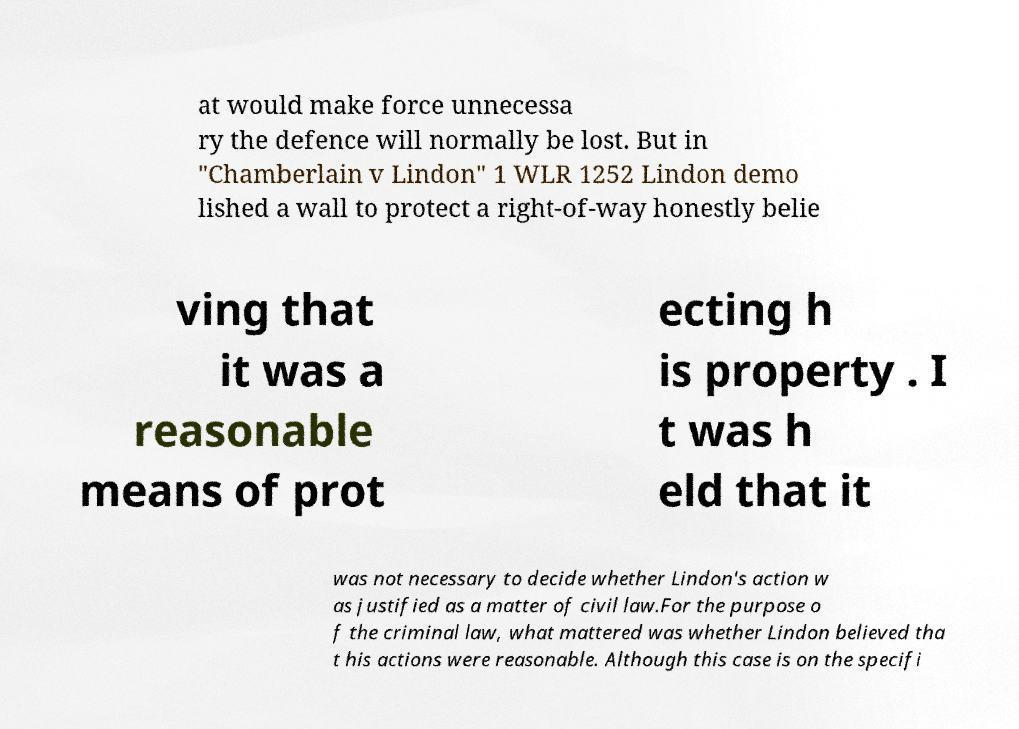Could you assist in decoding the text presented in this image and type it out clearly? at would make force unnecessa ry the defence will normally be lost. But in "Chamberlain v Lindon" 1 WLR 1252 Lindon demo lished a wall to protect a right-of-way honestly belie ving that it was a reasonable means of prot ecting h is property . I t was h eld that it was not necessary to decide whether Lindon's action w as justified as a matter of civil law.For the purpose o f the criminal law, what mattered was whether Lindon believed tha t his actions were reasonable. Although this case is on the specifi 